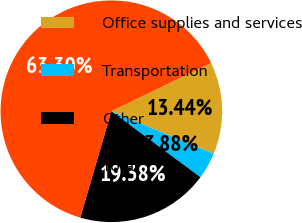Convert chart. <chart><loc_0><loc_0><loc_500><loc_500><pie_chart><fcel>Office supplies and services<fcel>Transportation<fcel>Other<fcel>Total<nl><fcel>13.44%<fcel>3.88%<fcel>19.38%<fcel>63.3%<nl></chart> 